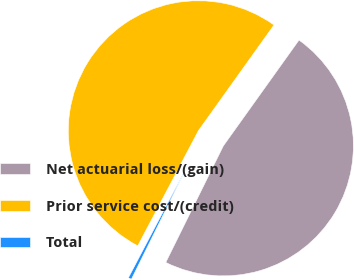Convert chart. <chart><loc_0><loc_0><loc_500><loc_500><pie_chart><fcel>Net actuarial loss/(gain)<fcel>Prior service cost/(credit)<fcel>Total<nl><fcel>47.42%<fcel>52.16%<fcel>0.41%<nl></chart> 